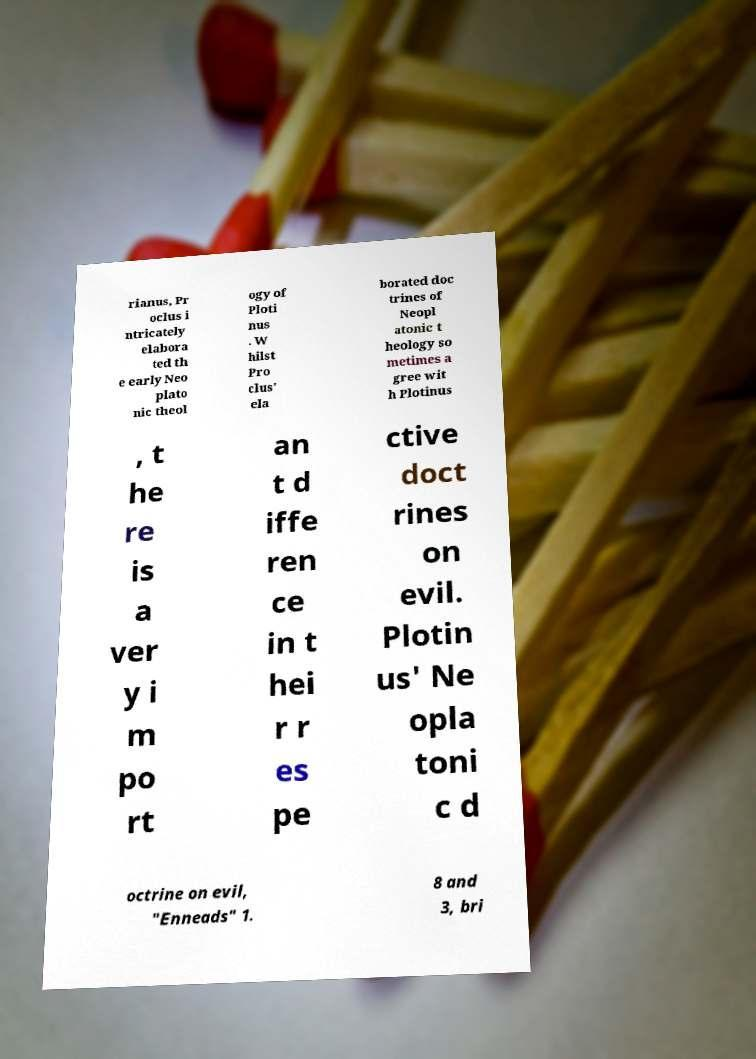Please identify and transcribe the text found in this image. rianus, Pr oclus i ntricately elabora ted th e early Neo plato nic theol ogy of Ploti nus . W hilst Pro clus' ela borated doc trines of Neopl atonic t heology so metimes a gree wit h Plotinus , t he re is a ver y i m po rt an t d iffe ren ce in t hei r r es pe ctive doct rines on evil. Plotin us' Ne opla toni c d octrine on evil, "Enneads" 1. 8 and 3, bri 